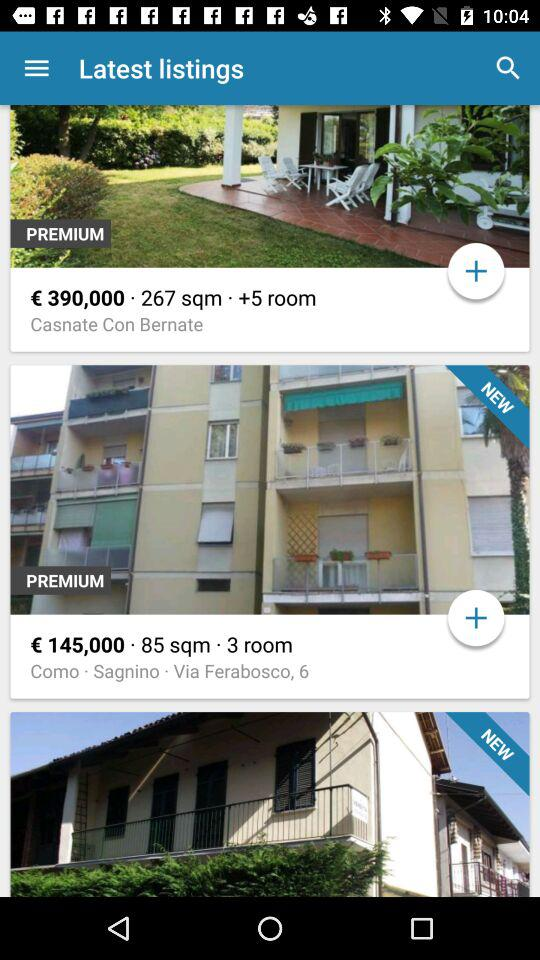What is the price of a house with 3 rooms? The price of a house with 3 rooms is €145,000. 